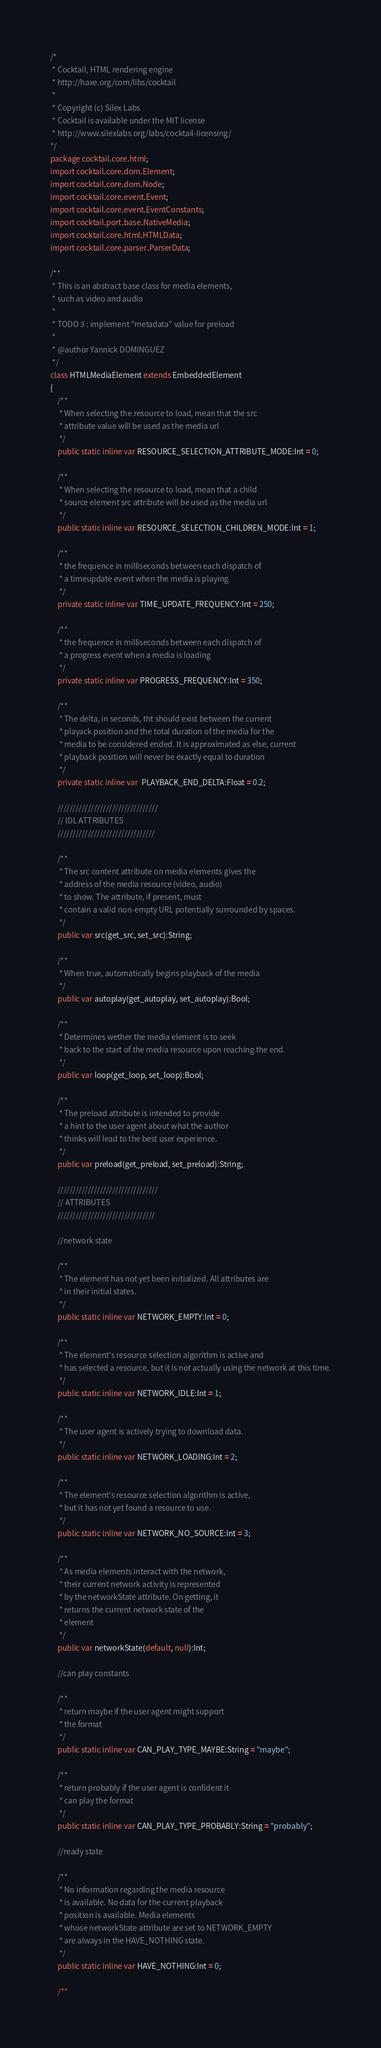<code> <loc_0><loc_0><loc_500><loc_500><_Haxe_>/*
 * Cocktail, HTML rendering engine
 * http://haxe.org/com/libs/cocktail
 *
 * Copyright (c) Silex Labs
 * Cocktail is available under the MIT license
 * http://www.silexlabs.org/labs/cocktail-licensing/
*/
package cocktail.core.html;
import cocktail.core.dom.Element;
import cocktail.core.dom.Node;
import cocktail.core.event.Event;
import cocktail.core.event.EventConstants;
import cocktail.port.base.NativeMedia;
import cocktail.core.html.HTMLData;
import cocktail.core.parser.ParserData;

/**
 * This is an abstract base class for media elements,
 * such as video and audio
 * 
 * TODO 3 : implement "metadata" value for preload
 * 
 * @author Yannick DOMINGUEZ
 */
class HTMLMediaElement extends EmbeddedElement
{
	/**
	 * When selecting the resource to load, mean that the src
	 * attribute value will be used as the media url
	 */
	public static inline var RESOURCE_SELECTION_ATTRIBUTE_MODE:Int = 0;
	
	/**
	 * When selecting the resource to load, mean that a child
	 * source element src attribute will be used as the media url
	 */
	public static inline var RESOURCE_SELECTION_CHILDREN_MODE:Int = 1;
	
	/**
	 * the frequence in milliseconds between each dispatch of
	 * a timeupdate event when the media is playing
	 */
	private static inline var TIME_UPDATE_FREQUENCY:Int = 250;
	
	/**
	 * the frequence in milliseconds between each dispatch of
	 * a progress event when a media is loading
	 */
	private static inline var PROGRESS_FREQUENCY:Int = 350;
	
	/**
	 * The delta, in seconds, tht should exist between the current 
	 * playack position and the total duration of the media for the
	 * media to be considered ended. It is approximated as else, current
	 * playback position will never be exactly equal to duration
	 */
	private static inline var  PLAYBACK_END_DELTA:Float = 0.2;
	
	/////////////////////////////////
	// IDL ATTRIBUTES
	////////////////////////////////
	
	/**
	 * The src content attribute on media elements gives the
	 * address of the media resource (video, audio)
	 * to show. The attribute, if present, must
	 * contain a valid non-empty URL potentially surrounded by spaces.
	 */
	public var src(get_src, set_src):String;
	
	/**
	 * When true, automatically begins playback of the media
	 */
	public var autoplay(get_autoplay, set_autoplay):Bool;
	
	/**
	 * Determines wether the media element is to seek
	 * back to the start of the media resource upon reaching the end.
	 */
	public var loop(get_loop, set_loop):Bool;
	
	/**
	 * The preload attribute is intended to provide
	 * a hint to the user agent about what the author
	 * thinks will lead to the best user experience. 
	 */
	public var preload(get_preload, set_preload):String;
	
	/////////////////////////////////
	// ATTRIBUTES
	////////////////////////////////
	
	//network state
	
	/**
	 * The element has not yet been initialized. All attributes are 
	 * in their initial states.
	 */
	public static inline var NETWORK_EMPTY:Int = 0;
	
	/**
	 * The element's resource selection algorithm is active and
	 * has selected a resource, but it is not actually using the network at this time.
	 */
	public static inline var NETWORK_IDLE:Int = 1;
	
	/**
	 * The user agent is actively trying to download data.
	 */
	public static inline var NETWORK_LOADING:Int = 2;
	
	/**
	 * The element's resource selection algorithm is active,
	 * but it has not yet found a resource to use.
	 */
	public static inline var NETWORK_NO_SOURCE:Int = 3;
	
	/**
	 * As media elements interact with the network,
	 * their current network activity is represented
	 * by the networkState attribute. On getting, it 
	 * returns the current network state of the
	 * element
	 */
	public var networkState(default, null):Int;
	
	//can play constants
	
	/**
	 * return maybe if the user agent might support 
	 * the format
	 */
	public static inline var CAN_PLAY_TYPE_MAYBE:String = "maybe";
	
	/**
	 * return probably if the user agent is confident it 
	 * can play the format
	 */
	public static inline var CAN_PLAY_TYPE_PROBABLY:String = "probably";
	
	//ready state
	
	/**
	 * No information regarding the media resource
	 * is available. No data for the current playback 
	 * position is available. Media elements
	 * whose networkState attribute are set to NETWORK_EMPTY
	 * are always in the HAVE_NOTHING state.
	 */
	public static inline var HAVE_NOTHING:Int = 0;
	
	/**</code> 